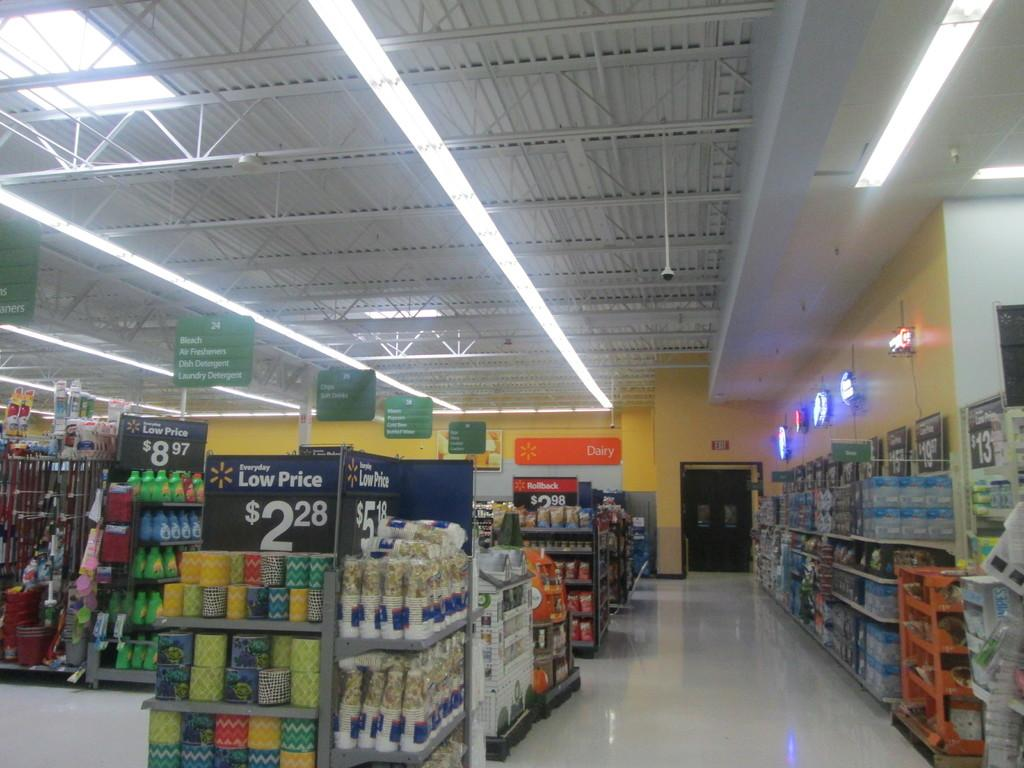<image>
Create a compact narrative representing the image presented. The inside of a Walmart shows a sale for $2.88. 